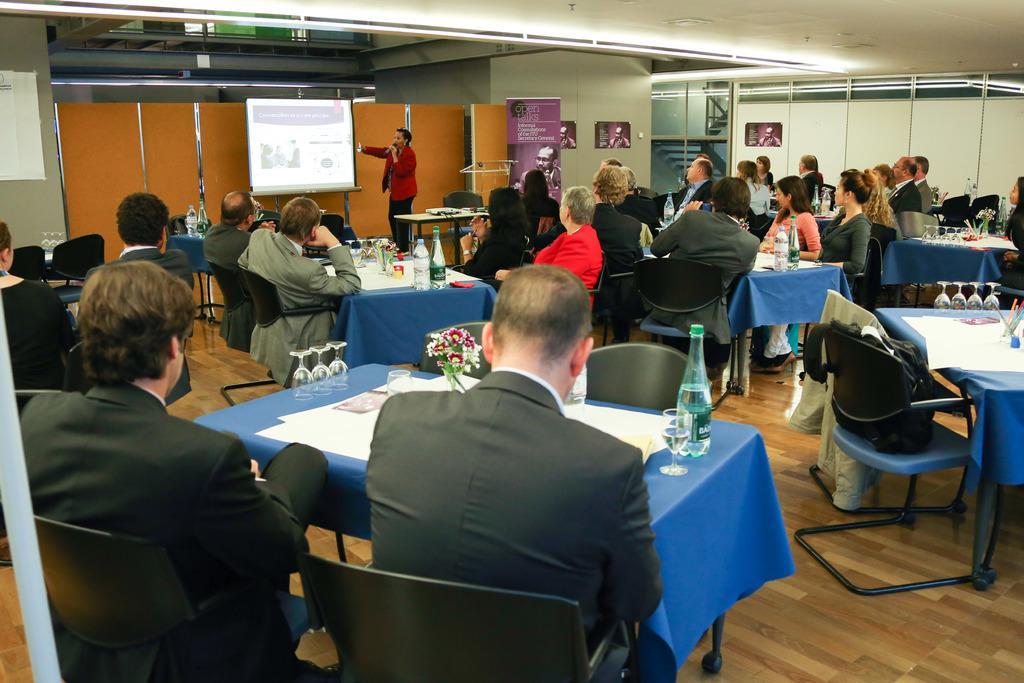Please provide a concise description of this image. It seems like there is a meeting going on. She is saying some topic or something. And she is holding mike. There are some persons present. They are sitting on chairs, in front of them there are tables present, tables present. And it seems like office meeting 